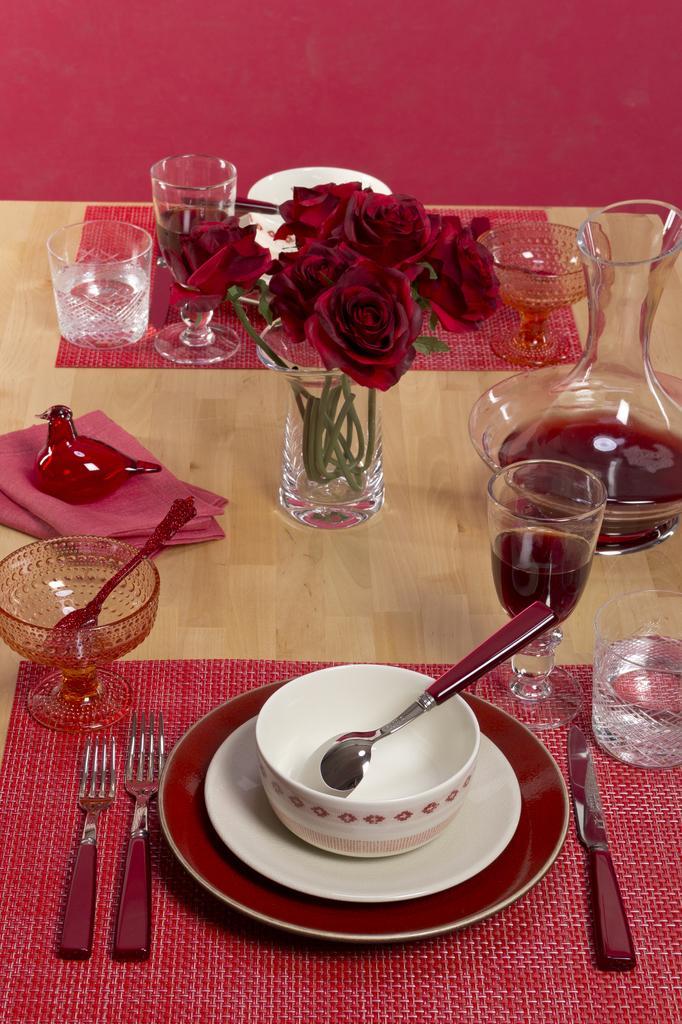In one or two sentences, can you explain what this image depicts? In this image, there are plates, bowls, spoons, forks, glass, flower vase and ice cream bowl which are kept on the table. The background wall is pink in color. This image is taken inside a room. 